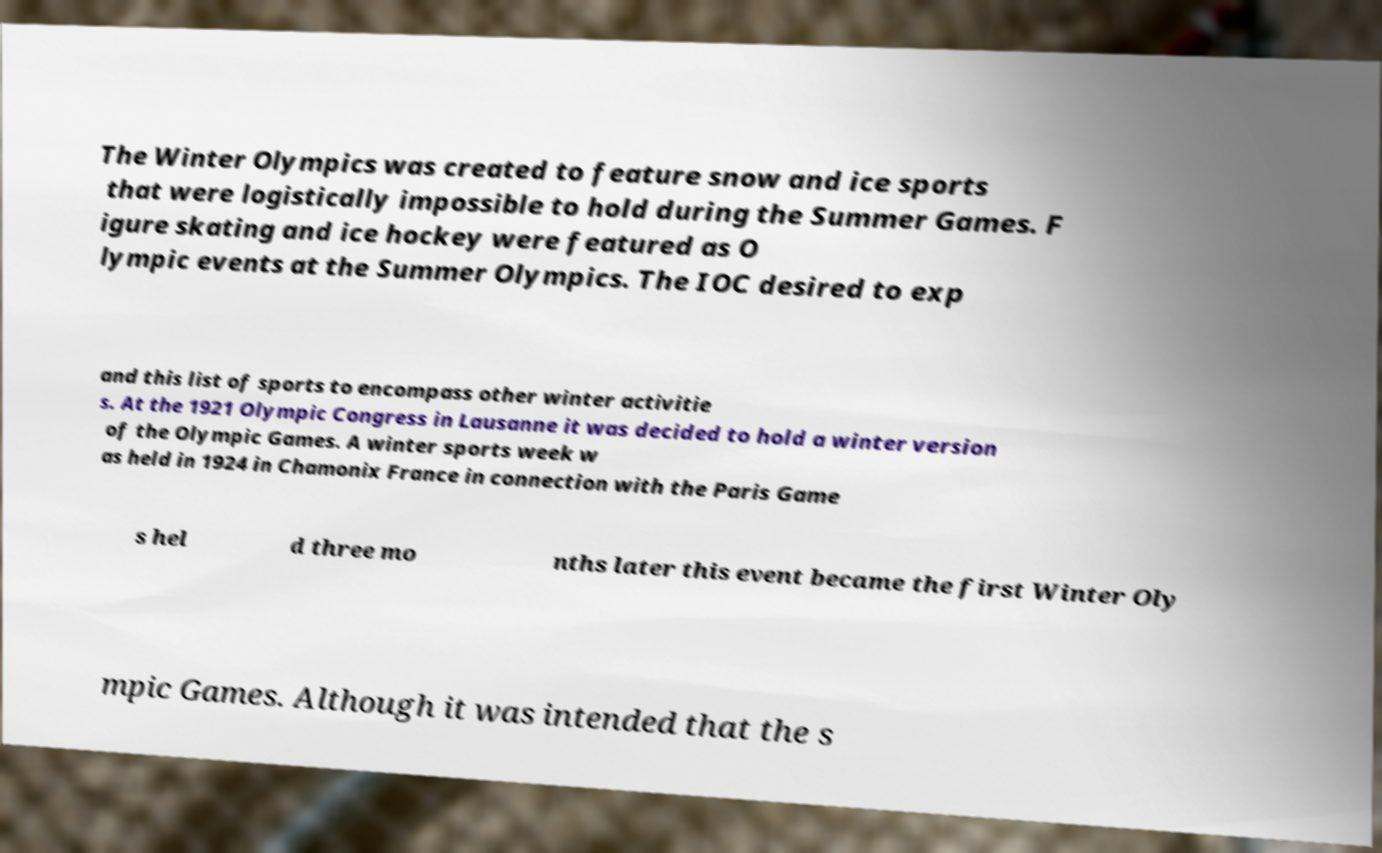For documentation purposes, I need the text within this image transcribed. Could you provide that? The Winter Olympics was created to feature snow and ice sports that were logistically impossible to hold during the Summer Games. F igure skating and ice hockey were featured as O lympic events at the Summer Olympics. The IOC desired to exp and this list of sports to encompass other winter activitie s. At the 1921 Olympic Congress in Lausanne it was decided to hold a winter version of the Olympic Games. A winter sports week w as held in 1924 in Chamonix France in connection with the Paris Game s hel d three mo nths later this event became the first Winter Oly mpic Games. Although it was intended that the s 